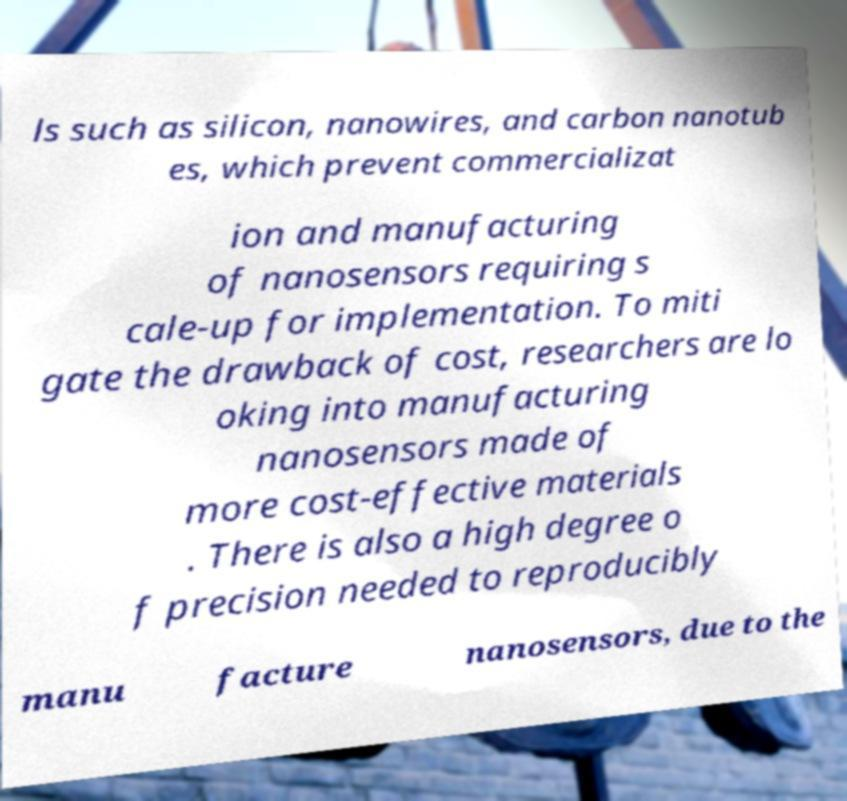Could you extract and type out the text from this image? ls such as silicon, nanowires, and carbon nanotub es, which prevent commercializat ion and manufacturing of nanosensors requiring s cale-up for implementation. To miti gate the drawback of cost, researchers are lo oking into manufacturing nanosensors made of more cost-effective materials . There is also a high degree o f precision needed to reproducibly manu facture nanosensors, due to the 